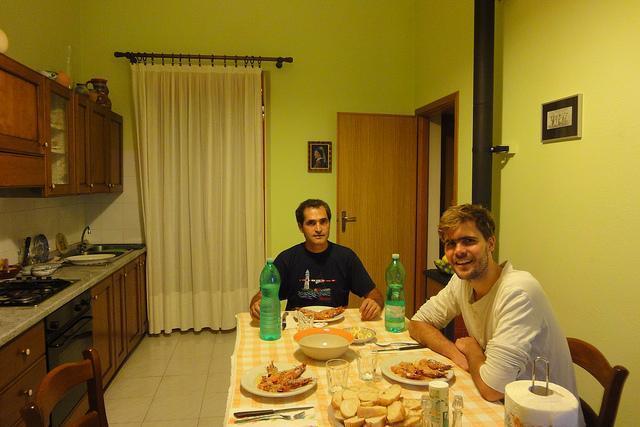How many men are sitting at the table?
Give a very brief answer. 2. How many beverages are on the table?
Give a very brief answer. 2. How many bottles are on table?
Give a very brief answer. 2. How many people are in this picture?
Give a very brief answer. 2. How many trays are on the table?
Give a very brief answer. 0. How many chairs are in the photo?
Give a very brief answer. 2. How many people can you see?
Give a very brief answer. 2. 